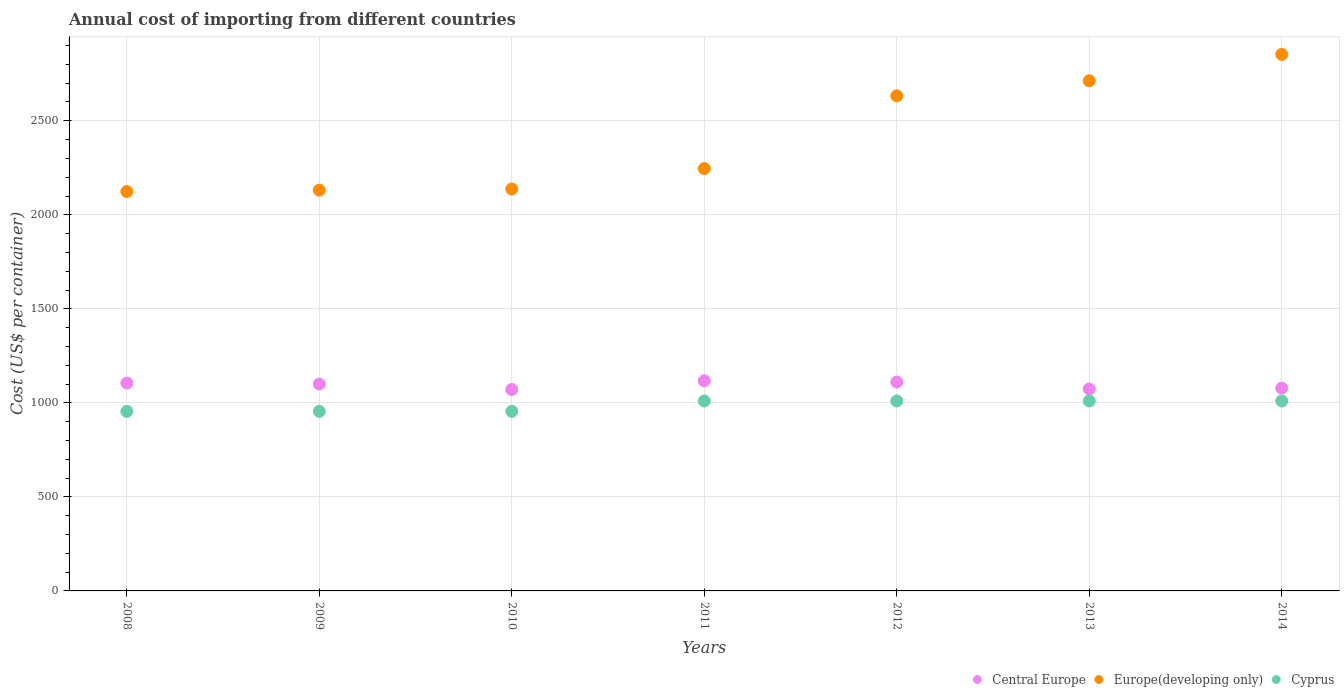How many different coloured dotlines are there?
Make the answer very short. 3. Is the number of dotlines equal to the number of legend labels?
Your answer should be very brief. Yes. What is the total annual cost of importing in Cyprus in 2014?
Provide a succinct answer. 1010. Across all years, what is the maximum total annual cost of importing in Europe(developing only)?
Provide a short and direct response. 2853. Across all years, what is the minimum total annual cost of importing in Central Europe?
Provide a succinct answer. 1071.09. What is the total total annual cost of importing in Cyprus in the graph?
Ensure brevity in your answer.  6905. What is the difference between the total annual cost of importing in Europe(developing only) in 2011 and that in 2012?
Your response must be concise. -387. What is the difference between the total annual cost of importing in Cyprus in 2011 and the total annual cost of importing in Europe(developing only) in 2012?
Offer a very short reply. -1622.79. What is the average total annual cost of importing in Cyprus per year?
Your response must be concise. 986.43. In the year 2008, what is the difference between the total annual cost of importing in Cyprus and total annual cost of importing in Europe(developing only)?
Provide a succinct answer. -1168.94. What is the ratio of the total annual cost of importing in Cyprus in 2008 to that in 2014?
Offer a terse response. 0.95. Is the total annual cost of importing in Cyprus in 2008 less than that in 2011?
Your answer should be compact. Yes. What is the difference between the highest and the second highest total annual cost of importing in Central Europe?
Make the answer very short. 6.82. What is the difference between the highest and the lowest total annual cost of importing in Cyprus?
Provide a succinct answer. 55. Is the sum of the total annual cost of importing in Cyprus in 2008 and 2011 greater than the maximum total annual cost of importing in Central Europe across all years?
Offer a very short reply. Yes. Is the total annual cost of importing in Cyprus strictly less than the total annual cost of importing in Europe(developing only) over the years?
Provide a succinct answer. Yes. How many dotlines are there?
Provide a succinct answer. 3. How many years are there in the graph?
Your response must be concise. 7. What is the difference between two consecutive major ticks on the Y-axis?
Make the answer very short. 500. Are the values on the major ticks of Y-axis written in scientific E-notation?
Ensure brevity in your answer.  No. How many legend labels are there?
Offer a terse response. 3. What is the title of the graph?
Your answer should be very brief. Annual cost of importing from different countries. What is the label or title of the X-axis?
Your response must be concise. Years. What is the label or title of the Y-axis?
Offer a terse response. Cost (US$ per container). What is the Cost (US$ per container) in Central Europe in 2008?
Ensure brevity in your answer.  1105.36. What is the Cost (US$ per container) of Europe(developing only) in 2008?
Your answer should be very brief. 2123.94. What is the Cost (US$ per container) in Cyprus in 2008?
Your answer should be very brief. 955. What is the Cost (US$ per container) of Central Europe in 2009?
Provide a succinct answer. 1100.18. What is the Cost (US$ per container) of Europe(developing only) in 2009?
Your response must be concise. 2131.11. What is the Cost (US$ per container) of Cyprus in 2009?
Provide a short and direct response. 955. What is the Cost (US$ per container) in Central Europe in 2010?
Your answer should be compact. 1071.09. What is the Cost (US$ per container) of Europe(developing only) in 2010?
Provide a short and direct response. 2137.16. What is the Cost (US$ per container) of Cyprus in 2010?
Your response must be concise. 955. What is the Cost (US$ per container) in Central Europe in 2011?
Provide a succinct answer. 1117.45. What is the Cost (US$ per container) in Europe(developing only) in 2011?
Give a very brief answer. 2245.79. What is the Cost (US$ per container) in Cyprus in 2011?
Make the answer very short. 1010. What is the Cost (US$ per container) in Central Europe in 2012?
Ensure brevity in your answer.  1110.64. What is the Cost (US$ per container) of Europe(developing only) in 2012?
Make the answer very short. 2632.79. What is the Cost (US$ per container) in Cyprus in 2012?
Give a very brief answer. 1010. What is the Cost (US$ per container) of Central Europe in 2013?
Make the answer very short. 1073.73. What is the Cost (US$ per container) of Europe(developing only) in 2013?
Offer a very short reply. 2713. What is the Cost (US$ per container) of Cyprus in 2013?
Provide a short and direct response. 1010. What is the Cost (US$ per container) in Central Europe in 2014?
Make the answer very short. 1078.27. What is the Cost (US$ per container) in Europe(developing only) in 2014?
Your answer should be very brief. 2853. What is the Cost (US$ per container) in Cyprus in 2014?
Give a very brief answer. 1010. Across all years, what is the maximum Cost (US$ per container) of Central Europe?
Keep it short and to the point. 1117.45. Across all years, what is the maximum Cost (US$ per container) of Europe(developing only)?
Offer a terse response. 2853. Across all years, what is the maximum Cost (US$ per container) in Cyprus?
Give a very brief answer. 1010. Across all years, what is the minimum Cost (US$ per container) in Central Europe?
Keep it short and to the point. 1071.09. Across all years, what is the minimum Cost (US$ per container) in Europe(developing only)?
Your answer should be compact. 2123.94. Across all years, what is the minimum Cost (US$ per container) in Cyprus?
Keep it short and to the point. 955. What is the total Cost (US$ per container) of Central Europe in the graph?
Your response must be concise. 7656.73. What is the total Cost (US$ per container) in Europe(developing only) in the graph?
Your response must be concise. 1.68e+04. What is the total Cost (US$ per container) in Cyprus in the graph?
Provide a succinct answer. 6905. What is the difference between the Cost (US$ per container) of Central Europe in 2008 and that in 2009?
Your answer should be compact. 5.18. What is the difference between the Cost (US$ per container) of Europe(developing only) in 2008 and that in 2009?
Provide a succinct answer. -7.16. What is the difference between the Cost (US$ per container) in Central Europe in 2008 and that in 2010?
Offer a terse response. 34.27. What is the difference between the Cost (US$ per container) in Europe(developing only) in 2008 and that in 2010?
Ensure brevity in your answer.  -13.21. What is the difference between the Cost (US$ per container) of Central Europe in 2008 and that in 2011?
Provide a succinct answer. -12.09. What is the difference between the Cost (US$ per container) in Europe(developing only) in 2008 and that in 2011?
Provide a short and direct response. -121.84. What is the difference between the Cost (US$ per container) in Cyprus in 2008 and that in 2011?
Your answer should be very brief. -55. What is the difference between the Cost (US$ per container) in Central Europe in 2008 and that in 2012?
Provide a succinct answer. -5.27. What is the difference between the Cost (US$ per container) in Europe(developing only) in 2008 and that in 2012?
Your answer should be compact. -508.85. What is the difference between the Cost (US$ per container) of Cyprus in 2008 and that in 2012?
Offer a terse response. -55. What is the difference between the Cost (US$ per container) of Central Europe in 2008 and that in 2013?
Give a very brief answer. 31.64. What is the difference between the Cost (US$ per container) of Europe(developing only) in 2008 and that in 2013?
Your answer should be compact. -589.06. What is the difference between the Cost (US$ per container) in Cyprus in 2008 and that in 2013?
Offer a terse response. -55. What is the difference between the Cost (US$ per container) in Central Europe in 2008 and that in 2014?
Offer a very short reply. 27.09. What is the difference between the Cost (US$ per container) of Europe(developing only) in 2008 and that in 2014?
Keep it short and to the point. -729.06. What is the difference between the Cost (US$ per container) in Cyprus in 2008 and that in 2014?
Ensure brevity in your answer.  -55. What is the difference between the Cost (US$ per container) in Central Europe in 2009 and that in 2010?
Offer a very short reply. 29.09. What is the difference between the Cost (US$ per container) in Europe(developing only) in 2009 and that in 2010?
Provide a succinct answer. -6.05. What is the difference between the Cost (US$ per container) of Central Europe in 2009 and that in 2011?
Offer a terse response. -17.27. What is the difference between the Cost (US$ per container) of Europe(developing only) in 2009 and that in 2011?
Make the answer very short. -114.68. What is the difference between the Cost (US$ per container) of Cyprus in 2009 and that in 2011?
Offer a terse response. -55. What is the difference between the Cost (US$ per container) of Central Europe in 2009 and that in 2012?
Provide a succinct answer. -10.45. What is the difference between the Cost (US$ per container) in Europe(developing only) in 2009 and that in 2012?
Provide a succinct answer. -501.68. What is the difference between the Cost (US$ per container) in Cyprus in 2009 and that in 2012?
Offer a terse response. -55. What is the difference between the Cost (US$ per container) in Central Europe in 2009 and that in 2013?
Your answer should be compact. 26.45. What is the difference between the Cost (US$ per container) of Europe(developing only) in 2009 and that in 2013?
Provide a short and direct response. -581.89. What is the difference between the Cost (US$ per container) of Cyprus in 2009 and that in 2013?
Make the answer very short. -55. What is the difference between the Cost (US$ per container) in Central Europe in 2009 and that in 2014?
Your answer should be very brief. 21.91. What is the difference between the Cost (US$ per container) in Europe(developing only) in 2009 and that in 2014?
Provide a succinct answer. -721.89. What is the difference between the Cost (US$ per container) in Cyprus in 2009 and that in 2014?
Give a very brief answer. -55. What is the difference between the Cost (US$ per container) of Central Europe in 2010 and that in 2011?
Your response must be concise. -46.36. What is the difference between the Cost (US$ per container) of Europe(developing only) in 2010 and that in 2011?
Give a very brief answer. -108.63. What is the difference between the Cost (US$ per container) in Cyprus in 2010 and that in 2011?
Give a very brief answer. -55. What is the difference between the Cost (US$ per container) in Central Europe in 2010 and that in 2012?
Offer a very short reply. -39.55. What is the difference between the Cost (US$ per container) in Europe(developing only) in 2010 and that in 2012?
Provide a short and direct response. -495.63. What is the difference between the Cost (US$ per container) of Cyprus in 2010 and that in 2012?
Make the answer very short. -55. What is the difference between the Cost (US$ per container) of Central Europe in 2010 and that in 2013?
Give a very brief answer. -2.64. What is the difference between the Cost (US$ per container) of Europe(developing only) in 2010 and that in 2013?
Provide a succinct answer. -575.84. What is the difference between the Cost (US$ per container) in Cyprus in 2010 and that in 2013?
Provide a short and direct response. -55. What is the difference between the Cost (US$ per container) in Central Europe in 2010 and that in 2014?
Make the answer very short. -7.18. What is the difference between the Cost (US$ per container) of Europe(developing only) in 2010 and that in 2014?
Your answer should be very brief. -715.84. What is the difference between the Cost (US$ per container) in Cyprus in 2010 and that in 2014?
Make the answer very short. -55. What is the difference between the Cost (US$ per container) in Central Europe in 2011 and that in 2012?
Give a very brief answer. 6.82. What is the difference between the Cost (US$ per container) of Europe(developing only) in 2011 and that in 2012?
Keep it short and to the point. -387. What is the difference between the Cost (US$ per container) in Cyprus in 2011 and that in 2012?
Ensure brevity in your answer.  0. What is the difference between the Cost (US$ per container) in Central Europe in 2011 and that in 2013?
Your answer should be compact. 43.73. What is the difference between the Cost (US$ per container) of Europe(developing only) in 2011 and that in 2013?
Your response must be concise. -467.21. What is the difference between the Cost (US$ per container) of Cyprus in 2011 and that in 2013?
Your response must be concise. 0. What is the difference between the Cost (US$ per container) in Central Europe in 2011 and that in 2014?
Offer a terse response. 39.18. What is the difference between the Cost (US$ per container) of Europe(developing only) in 2011 and that in 2014?
Offer a terse response. -607.21. What is the difference between the Cost (US$ per container) of Cyprus in 2011 and that in 2014?
Offer a terse response. 0. What is the difference between the Cost (US$ per container) of Central Europe in 2012 and that in 2013?
Provide a succinct answer. 36.91. What is the difference between the Cost (US$ per container) of Europe(developing only) in 2012 and that in 2013?
Give a very brief answer. -80.21. What is the difference between the Cost (US$ per container) of Cyprus in 2012 and that in 2013?
Keep it short and to the point. 0. What is the difference between the Cost (US$ per container) in Central Europe in 2012 and that in 2014?
Your answer should be compact. 32.36. What is the difference between the Cost (US$ per container) of Europe(developing only) in 2012 and that in 2014?
Make the answer very short. -220.21. What is the difference between the Cost (US$ per container) in Central Europe in 2013 and that in 2014?
Provide a succinct answer. -4.55. What is the difference between the Cost (US$ per container) of Europe(developing only) in 2013 and that in 2014?
Give a very brief answer. -140. What is the difference between the Cost (US$ per container) in Central Europe in 2008 and the Cost (US$ per container) in Europe(developing only) in 2009?
Keep it short and to the point. -1025.74. What is the difference between the Cost (US$ per container) of Central Europe in 2008 and the Cost (US$ per container) of Cyprus in 2009?
Give a very brief answer. 150.36. What is the difference between the Cost (US$ per container) of Europe(developing only) in 2008 and the Cost (US$ per container) of Cyprus in 2009?
Provide a succinct answer. 1168.94. What is the difference between the Cost (US$ per container) of Central Europe in 2008 and the Cost (US$ per container) of Europe(developing only) in 2010?
Keep it short and to the point. -1031.79. What is the difference between the Cost (US$ per container) of Central Europe in 2008 and the Cost (US$ per container) of Cyprus in 2010?
Provide a succinct answer. 150.36. What is the difference between the Cost (US$ per container) of Europe(developing only) in 2008 and the Cost (US$ per container) of Cyprus in 2010?
Offer a terse response. 1168.94. What is the difference between the Cost (US$ per container) in Central Europe in 2008 and the Cost (US$ per container) in Europe(developing only) in 2011?
Provide a succinct answer. -1140.43. What is the difference between the Cost (US$ per container) of Central Europe in 2008 and the Cost (US$ per container) of Cyprus in 2011?
Your response must be concise. 95.36. What is the difference between the Cost (US$ per container) in Europe(developing only) in 2008 and the Cost (US$ per container) in Cyprus in 2011?
Make the answer very short. 1113.94. What is the difference between the Cost (US$ per container) in Central Europe in 2008 and the Cost (US$ per container) in Europe(developing only) in 2012?
Offer a terse response. -1527.43. What is the difference between the Cost (US$ per container) of Central Europe in 2008 and the Cost (US$ per container) of Cyprus in 2012?
Your answer should be very brief. 95.36. What is the difference between the Cost (US$ per container) in Europe(developing only) in 2008 and the Cost (US$ per container) in Cyprus in 2012?
Provide a short and direct response. 1113.94. What is the difference between the Cost (US$ per container) of Central Europe in 2008 and the Cost (US$ per container) of Europe(developing only) in 2013?
Keep it short and to the point. -1607.64. What is the difference between the Cost (US$ per container) in Central Europe in 2008 and the Cost (US$ per container) in Cyprus in 2013?
Your answer should be very brief. 95.36. What is the difference between the Cost (US$ per container) of Europe(developing only) in 2008 and the Cost (US$ per container) of Cyprus in 2013?
Provide a succinct answer. 1113.94. What is the difference between the Cost (US$ per container) in Central Europe in 2008 and the Cost (US$ per container) in Europe(developing only) in 2014?
Keep it short and to the point. -1747.64. What is the difference between the Cost (US$ per container) in Central Europe in 2008 and the Cost (US$ per container) in Cyprus in 2014?
Make the answer very short. 95.36. What is the difference between the Cost (US$ per container) of Europe(developing only) in 2008 and the Cost (US$ per container) of Cyprus in 2014?
Provide a succinct answer. 1113.94. What is the difference between the Cost (US$ per container) of Central Europe in 2009 and the Cost (US$ per container) of Europe(developing only) in 2010?
Ensure brevity in your answer.  -1036.98. What is the difference between the Cost (US$ per container) in Central Europe in 2009 and the Cost (US$ per container) in Cyprus in 2010?
Offer a terse response. 145.18. What is the difference between the Cost (US$ per container) in Europe(developing only) in 2009 and the Cost (US$ per container) in Cyprus in 2010?
Ensure brevity in your answer.  1176.11. What is the difference between the Cost (US$ per container) of Central Europe in 2009 and the Cost (US$ per container) of Europe(developing only) in 2011?
Provide a short and direct response. -1145.61. What is the difference between the Cost (US$ per container) in Central Europe in 2009 and the Cost (US$ per container) in Cyprus in 2011?
Give a very brief answer. 90.18. What is the difference between the Cost (US$ per container) in Europe(developing only) in 2009 and the Cost (US$ per container) in Cyprus in 2011?
Provide a succinct answer. 1121.11. What is the difference between the Cost (US$ per container) of Central Europe in 2009 and the Cost (US$ per container) of Europe(developing only) in 2012?
Offer a very short reply. -1532.61. What is the difference between the Cost (US$ per container) in Central Europe in 2009 and the Cost (US$ per container) in Cyprus in 2012?
Offer a very short reply. 90.18. What is the difference between the Cost (US$ per container) of Europe(developing only) in 2009 and the Cost (US$ per container) of Cyprus in 2012?
Your response must be concise. 1121.11. What is the difference between the Cost (US$ per container) of Central Europe in 2009 and the Cost (US$ per container) of Europe(developing only) in 2013?
Your response must be concise. -1612.82. What is the difference between the Cost (US$ per container) in Central Europe in 2009 and the Cost (US$ per container) in Cyprus in 2013?
Your answer should be compact. 90.18. What is the difference between the Cost (US$ per container) in Europe(developing only) in 2009 and the Cost (US$ per container) in Cyprus in 2013?
Make the answer very short. 1121.11. What is the difference between the Cost (US$ per container) of Central Europe in 2009 and the Cost (US$ per container) of Europe(developing only) in 2014?
Your answer should be very brief. -1752.82. What is the difference between the Cost (US$ per container) in Central Europe in 2009 and the Cost (US$ per container) in Cyprus in 2014?
Give a very brief answer. 90.18. What is the difference between the Cost (US$ per container) in Europe(developing only) in 2009 and the Cost (US$ per container) in Cyprus in 2014?
Your answer should be very brief. 1121.11. What is the difference between the Cost (US$ per container) of Central Europe in 2010 and the Cost (US$ per container) of Europe(developing only) in 2011?
Your answer should be compact. -1174.7. What is the difference between the Cost (US$ per container) in Central Europe in 2010 and the Cost (US$ per container) in Cyprus in 2011?
Your answer should be very brief. 61.09. What is the difference between the Cost (US$ per container) of Europe(developing only) in 2010 and the Cost (US$ per container) of Cyprus in 2011?
Provide a succinct answer. 1127.16. What is the difference between the Cost (US$ per container) of Central Europe in 2010 and the Cost (US$ per container) of Europe(developing only) in 2012?
Offer a very short reply. -1561.7. What is the difference between the Cost (US$ per container) in Central Europe in 2010 and the Cost (US$ per container) in Cyprus in 2012?
Make the answer very short. 61.09. What is the difference between the Cost (US$ per container) of Europe(developing only) in 2010 and the Cost (US$ per container) of Cyprus in 2012?
Your response must be concise. 1127.16. What is the difference between the Cost (US$ per container) in Central Europe in 2010 and the Cost (US$ per container) in Europe(developing only) in 2013?
Offer a terse response. -1641.91. What is the difference between the Cost (US$ per container) in Central Europe in 2010 and the Cost (US$ per container) in Cyprus in 2013?
Provide a succinct answer. 61.09. What is the difference between the Cost (US$ per container) in Europe(developing only) in 2010 and the Cost (US$ per container) in Cyprus in 2013?
Make the answer very short. 1127.16. What is the difference between the Cost (US$ per container) in Central Europe in 2010 and the Cost (US$ per container) in Europe(developing only) in 2014?
Your answer should be very brief. -1781.91. What is the difference between the Cost (US$ per container) in Central Europe in 2010 and the Cost (US$ per container) in Cyprus in 2014?
Provide a short and direct response. 61.09. What is the difference between the Cost (US$ per container) in Europe(developing only) in 2010 and the Cost (US$ per container) in Cyprus in 2014?
Provide a short and direct response. 1127.16. What is the difference between the Cost (US$ per container) of Central Europe in 2011 and the Cost (US$ per container) of Europe(developing only) in 2012?
Keep it short and to the point. -1515.33. What is the difference between the Cost (US$ per container) in Central Europe in 2011 and the Cost (US$ per container) in Cyprus in 2012?
Your response must be concise. 107.45. What is the difference between the Cost (US$ per container) of Europe(developing only) in 2011 and the Cost (US$ per container) of Cyprus in 2012?
Your answer should be very brief. 1235.79. What is the difference between the Cost (US$ per container) of Central Europe in 2011 and the Cost (US$ per container) of Europe(developing only) in 2013?
Offer a very short reply. -1595.55. What is the difference between the Cost (US$ per container) of Central Europe in 2011 and the Cost (US$ per container) of Cyprus in 2013?
Make the answer very short. 107.45. What is the difference between the Cost (US$ per container) in Europe(developing only) in 2011 and the Cost (US$ per container) in Cyprus in 2013?
Your response must be concise. 1235.79. What is the difference between the Cost (US$ per container) of Central Europe in 2011 and the Cost (US$ per container) of Europe(developing only) in 2014?
Provide a short and direct response. -1735.55. What is the difference between the Cost (US$ per container) in Central Europe in 2011 and the Cost (US$ per container) in Cyprus in 2014?
Give a very brief answer. 107.45. What is the difference between the Cost (US$ per container) in Europe(developing only) in 2011 and the Cost (US$ per container) in Cyprus in 2014?
Provide a succinct answer. 1235.79. What is the difference between the Cost (US$ per container) of Central Europe in 2012 and the Cost (US$ per container) of Europe(developing only) in 2013?
Your answer should be compact. -1602.36. What is the difference between the Cost (US$ per container) of Central Europe in 2012 and the Cost (US$ per container) of Cyprus in 2013?
Ensure brevity in your answer.  100.64. What is the difference between the Cost (US$ per container) of Europe(developing only) in 2012 and the Cost (US$ per container) of Cyprus in 2013?
Make the answer very short. 1622.79. What is the difference between the Cost (US$ per container) of Central Europe in 2012 and the Cost (US$ per container) of Europe(developing only) in 2014?
Offer a very short reply. -1742.36. What is the difference between the Cost (US$ per container) in Central Europe in 2012 and the Cost (US$ per container) in Cyprus in 2014?
Provide a succinct answer. 100.64. What is the difference between the Cost (US$ per container) of Europe(developing only) in 2012 and the Cost (US$ per container) of Cyprus in 2014?
Provide a succinct answer. 1622.79. What is the difference between the Cost (US$ per container) of Central Europe in 2013 and the Cost (US$ per container) of Europe(developing only) in 2014?
Provide a succinct answer. -1779.27. What is the difference between the Cost (US$ per container) in Central Europe in 2013 and the Cost (US$ per container) in Cyprus in 2014?
Provide a succinct answer. 63.73. What is the difference between the Cost (US$ per container) of Europe(developing only) in 2013 and the Cost (US$ per container) of Cyprus in 2014?
Provide a succinct answer. 1703. What is the average Cost (US$ per container) in Central Europe per year?
Provide a succinct answer. 1093.82. What is the average Cost (US$ per container) in Europe(developing only) per year?
Your answer should be very brief. 2405.26. What is the average Cost (US$ per container) of Cyprus per year?
Your response must be concise. 986.43. In the year 2008, what is the difference between the Cost (US$ per container) in Central Europe and Cost (US$ per container) in Europe(developing only)?
Keep it short and to the point. -1018.58. In the year 2008, what is the difference between the Cost (US$ per container) in Central Europe and Cost (US$ per container) in Cyprus?
Give a very brief answer. 150.36. In the year 2008, what is the difference between the Cost (US$ per container) of Europe(developing only) and Cost (US$ per container) of Cyprus?
Your response must be concise. 1168.94. In the year 2009, what is the difference between the Cost (US$ per container) of Central Europe and Cost (US$ per container) of Europe(developing only)?
Provide a short and direct response. -1030.92. In the year 2009, what is the difference between the Cost (US$ per container) in Central Europe and Cost (US$ per container) in Cyprus?
Offer a terse response. 145.18. In the year 2009, what is the difference between the Cost (US$ per container) of Europe(developing only) and Cost (US$ per container) of Cyprus?
Give a very brief answer. 1176.11. In the year 2010, what is the difference between the Cost (US$ per container) in Central Europe and Cost (US$ per container) in Europe(developing only)?
Provide a succinct answer. -1066.07. In the year 2010, what is the difference between the Cost (US$ per container) in Central Europe and Cost (US$ per container) in Cyprus?
Keep it short and to the point. 116.09. In the year 2010, what is the difference between the Cost (US$ per container) of Europe(developing only) and Cost (US$ per container) of Cyprus?
Your answer should be very brief. 1182.16. In the year 2011, what is the difference between the Cost (US$ per container) in Central Europe and Cost (US$ per container) in Europe(developing only)?
Your answer should be compact. -1128.33. In the year 2011, what is the difference between the Cost (US$ per container) of Central Europe and Cost (US$ per container) of Cyprus?
Give a very brief answer. 107.45. In the year 2011, what is the difference between the Cost (US$ per container) of Europe(developing only) and Cost (US$ per container) of Cyprus?
Give a very brief answer. 1235.79. In the year 2012, what is the difference between the Cost (US$ per container) of Central Europe and Cost (US$ per container) of Europe(developing only)?
Give a very brief answer. -1522.15. In the year 2012, what is the difference between the Cost (US$ per container) in Central Europe and Cost (US$ per container) in Cyprus?
Ensure brevity in your answer.  100.64. In the year 2012, what is the difference between the Cost (US$ per container) in Europe(developing only) and Cost (US$ per container) in Cyprus?
Provide a short and direct response. 1622.79. In the year 2013, what is the difference between the Cost (US$ per container) in Central Europe and Cost (US$ per container) in Europe(developing only)?
Give a very brief answer. -1639.27. In the year 2013, what is the difference between the Cost (US$ per container) of Central Europe and Cost (US$ per container) of Cyprus?
Keep it short and to the point. 63.73. In the year 2013, what is the difference between the Cost (US$ per container) of Europe(developing only) and Cost (US$ per container) of Cyprus?
Your answer should be very brief. 1703. In the year 2014, what is the difference between the Cost (US$ per container) in Central Europe and Cost (US$ per container) in Europe(developing only)?
Keep it short and to the point. -1774.73. In the year 2014, what is the difference between the Cost (US$ per container) in Central Europe and Cost (US$ per container) in Cyprus?
Provide a short and direct response. 68.27. In the year 2014, what is the difference between the Cost (US$ per container) of Europe(developing only) and Cost (US$ per container) of Cyprus?
Keep it short and to the point. 1843. What is the ratio of the Cost (US$ per container) of Central Europe in 2008 to that in 2009?
Provide a short and direct response. 1. What is the ratio of the Cost (US$ per container) in Europe(developing only) in 2008 to that in 2009?
Provide a succinct answer. 1. What is the ratio of the Cost (US$ per container) of Central Europe in 2008 to that in 2010?
Your response must be concise. 1.03. What is the ratio of the Cost (US$ per container) in Cyprus in 2008 to that in 2010?
Your response must be concise. 1. What is the ratio of the Cost (US$ per container) in Central Europe in 2008 to that in 2011?
Keep it short and to the point. 0.99. What is the ratio of the Cost (US$ per container) in Europe(developing only) in 2008 to that in 2011?
Provide a succinct answer. 0.95. What is the ratio of the Cost (US$ per container) of Cyprus in 2008 to that in 2011?
Ensure brevity in your answer.  0.95. What is the ratio of the Cost (US$ per container) in Central Europe in 2008 to that in 2012?
Your answer should be compact. 1. What is the ratio of the Cost (US$ per container) of Europe(developing only) in 2008 to that in 2012?
Give a very brief answer. 0.81. What is the ratio of the Cost (US$ per container) of Cyprus in 2008 to that in 2012?
Provide a short and direct response. 0.95. What is the ratio of the Cost (US$ per container) in Central Europe in 2008 to that in 2013?
Provide a succinct answer. 1.03. What is the ratio of the Cost (US$ per container) of Europe(developing only) in 2008 to that in 2013?
Offer a terse response. 0.78. What is the ratio of the Cost (US$ per container) of Cyprus in 2008 to that in 2013?
Give a very brief answer. 0.95. What is the ratio of the Cost (US$ per container) in Central Europe in 2008 to that in 2014?
Offer a very short reply. 1.03. What is the ratio of the Cost (US$ per container) in Europe(developing only) in 2008 to that in 2014?
Your answer should be very brief. 0.74. What is the ratio of the Cost (US$ per container) in Cyprus in 2008 to that in 2014?
Make the answer very short. 0.95. What is the ratio of the Cost (US$ per container) in Central Europe in 2009 to that in 2010?
Keep it short and to the point. 1.03. What is the ratio of the Cost (US$ per container) of Europe(developing only) in 2009 to that in 2010?
Offer a very short reply. 1. What is the ratio of the Cost (US$ per container) in Central Europe in 2009 to that in 2011?
Offer a terse response. 0.98. What is the ratio of the Cost (US$ per container) of Europe(developing only) in 2009 to that in 2011?
Ensure brevity in your answer.  0.95. What is the ratio of the Cost (US$ per container) of Cyprus in 2009 to that in 2011?
Keep it short and to the point. 0.95. What is the ratio of the Cost (US$ per container) in Central Europe in 2009 to that in 2012?
Make the answer very short. 0.99. What is the ratio of the Cost (US$ per container) of Europe(developing only) in 2009 to that in 2012?
Offer a terse response. 0.81. What is the ratio of the Cost (US$ per container) of Cyprus in 2009 to that in 2012?
Your answer should be compact. 0.95. What is the ratio of the Cost (US$ per container) in Central Europe in 2009 to that in 2013?
Give a very brief answer. 1.02. What is the ratio of the Cost (US$ per container) in Europe(developing only) in 2009 to that in 2013?
Ensure brevity in your answer.  0.79. What is the ratio of the Cost (US$ per container) of Cyprus in 2009 to that in 2013?
Keep it short and to the point. 0.95. What is the ratio of the Cost (US$ per container) in Central Europe in 2009 to that in 2014?
Offer a terse response. 1.02. What is the ratio of the Cost (US$ per container) in Europe(developing only) in 2009 to that in 2014?
Make the answer very short. 0.75. What is the ratio of the Cost (US$ per container) of Cyprus in 2009 to that in 2014?
Provide a short and direct response. 0.95. What is the ratio of the Cost (US$ per container) in Central Europe in 2010 to that in 2011?
Provide a short and direct response. 0.96. What is the ratio of the Cost (US$ per container) of Europe(developing only) in 2010 to that in 2011?
Offer a terse response. 0.95. What is the ratio of the Cost (US$ per container) in Cyprus in 2010 to that in 2011?
Give a very brief answer. 0.95. What is the ratio of the Cost (US$ per container) in Central Europe in 2010 to that in 2012?
Your answer should be very brief. 0.96. What is the ratio of the Cost (US$ per container) in Europe(developing only) in 2010 to that in 2012?
Make the answer very short. 0.81. What is the ratio of the Cost (US$ per container) in Cyprus in 2010 to that in 2012?
Keep it short and to the point. 0.95. What is the ratio of the Cost (US$ per container) of Central Europe in 2010 to that in 2013?
Your answer should be very brief. 1. What is the ratio of the Cost (US$ per container) in Europe(developing only) in 2010 to that in 2013?
Make the answer very short. 0.79. What is the ratio of the Cost (US$ per container) of Cyprus in 2010 to that in 2013?
Make the answer very short. 0.95. What is the ratio of the Cost (US$ per container) of Central Europe in 2010 to that in 2014?
Provide a short and direct response. 0.99. What is the ratio of the Cost (US$ per container) of Europe(developing only) in 2010 to that in 2014?
Give a very brief answer. 0.75. What is the ratio of the Cost (US$ per container) of Cyprus in 2010 to that in 2014?
Your answer should be very brief. 0.95. What is the ratio of the Cost (US$ per container) in Central Europe in 2011 to that in 2012?
Offer a very short reply. 1.01. What is the ratio of the Cost (US$ per container) in Europe(developing only) in 2011 to that in 2012?
Provide a succinct answer. 0.85. What is the ratio of the Cost (US$ per container) of Cyprus in 2011 to that in 2012?
Offer a terse response. 1. What is the ratio of the Cost (US$ per container) of Central Europe in 2011 to that in 2013?
Make the answer very short. 1.04. What is the ratio of the Cost (US$ per container) of Europe(developing only) in 2011 to that in 2013?
Your response must be concise. 0.83. What is the ratio of the Cost (US$ per container) in Central Europe in 2011 to that in 2014?
Ensure brevity in your answer.  1.04. What is the ratio of the Cost (US$ per container) of Europe(developing only) in 2011 to that in 2014?
Give a very brief answer. 0.79. What is the ratio of the Cost (US$ per container) in Cyprus in 2011 to that in 2014?
Your response must be concise. 1. What is the ratio of the Cost (US$ per container) in Central Europe in 2012 to that in 2013?
Offer a terse response. 1.03. What is the ratio of the Cost (US$ per container) in Europe(developing only) in 2012 to that in 2013?
Your answer should be compact. 0.97. What is the ratio of the Cost (US$ per container) in Central Europe in 2012 to that in 2014?
Give a very brief answer. 1.03. What is the ratio of the Cost (US$ per container) in Europe(developing only) in 2012 to that in 2014?
Ensure brevity in your answer.  0.92. What is the ratio of the Cost (US$ per container) in Cyprus in 2012 to that in 2014?
Keep it short and to the point. 1. What is the ratio of the Cost (US$ per container) of Central Europe in 2013 to that in 2014?
Your response must be concise. 1. What is the ratio of the Cost (US$ per container) of Europe(developing only) in 2013 to that in 2014?
Offer a terse response. 0.95. What is the difference between the highest and the second highest Cost (US$ per container) of Central Europe?
Provide a short and direct response. 6.82. What is the difference between the highest and the second highest Cost (US$ per container) of Europe(developing only)?
Ensure brevity in your answer.  140. What is the difference between the highest and the lowest Cost (US$ per container) of Central Europe?
Provide a short and direct response. 46.36. What is the difference between the highest and the lowest Cost (US$ per container) of Europe(developing only)?
Provide a short and direct response. 729.06. 